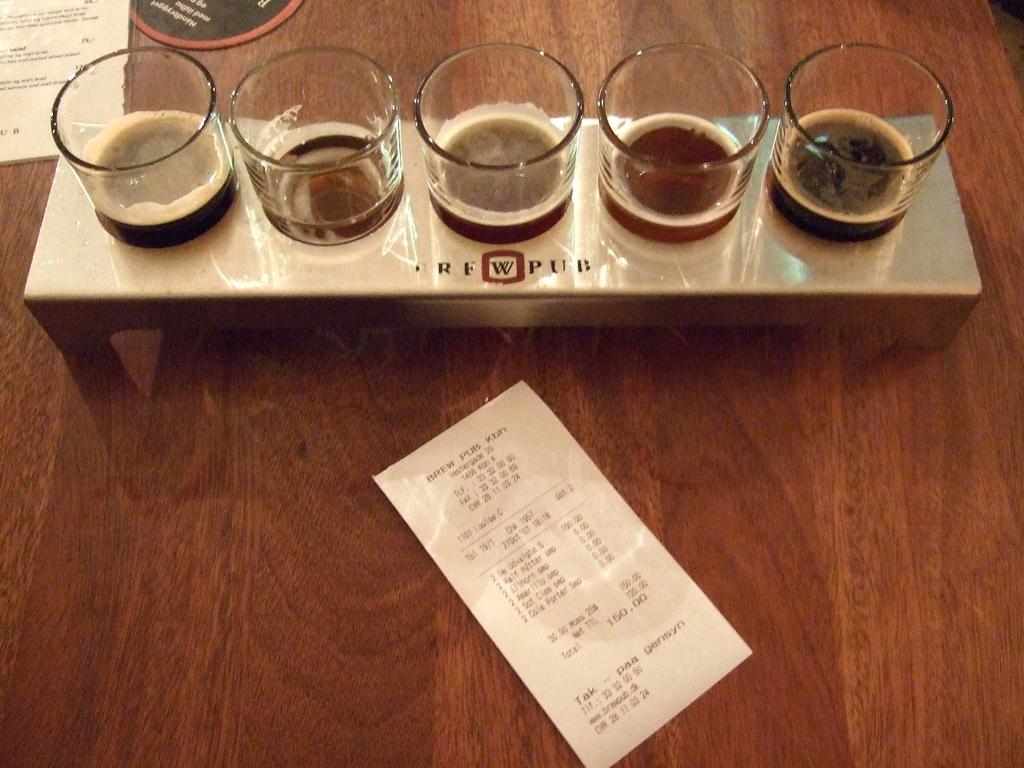How many glasses are in the stand in the image? There are five glasses in a stand in the image. What else is on the table in the image? There is a bill and a menu card on the table in the image. Can you describe the setting where the image might have been taken? The image may have been taken in a hotel. How many beds are visible in the image? There are no beds visible in the image. What type of pot is used to serve the food in the image? There is no pot visible in the image, and no food is being served. 